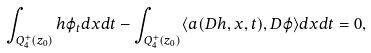<formula> <loc_0><loc_0><loc_500><loc_500>\int _ { Q ^ { + } _ { 4 } ( z _ { 0 } ) } h \varphi _ { t } d x d t - \int _ { Q ^ { + } _ { 4 } ( z _ { 0 } ) } \langle { a } ( D h , x , t ) , D \varphi \rangle d x d t = 0 ,</formula> 